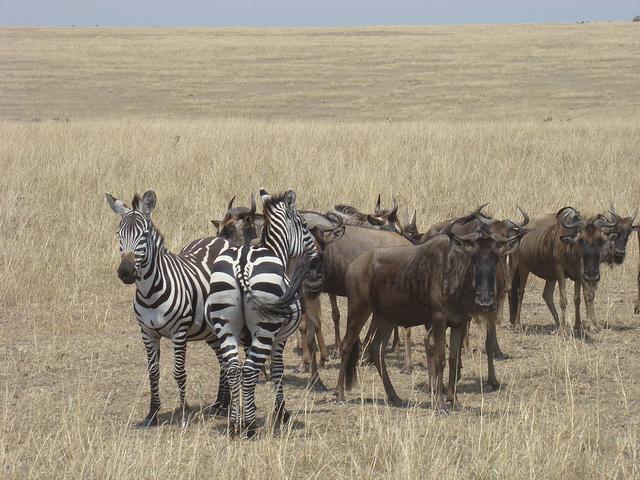How many zebras are seen?
Give a very brief answer. 2. How many zebras are looking at the camera?
Give a very brief answer. 1. How many cows are there?
Give a very brief answer. 3. How many zebras are in the picture?
Give a very brief answer. 2. 